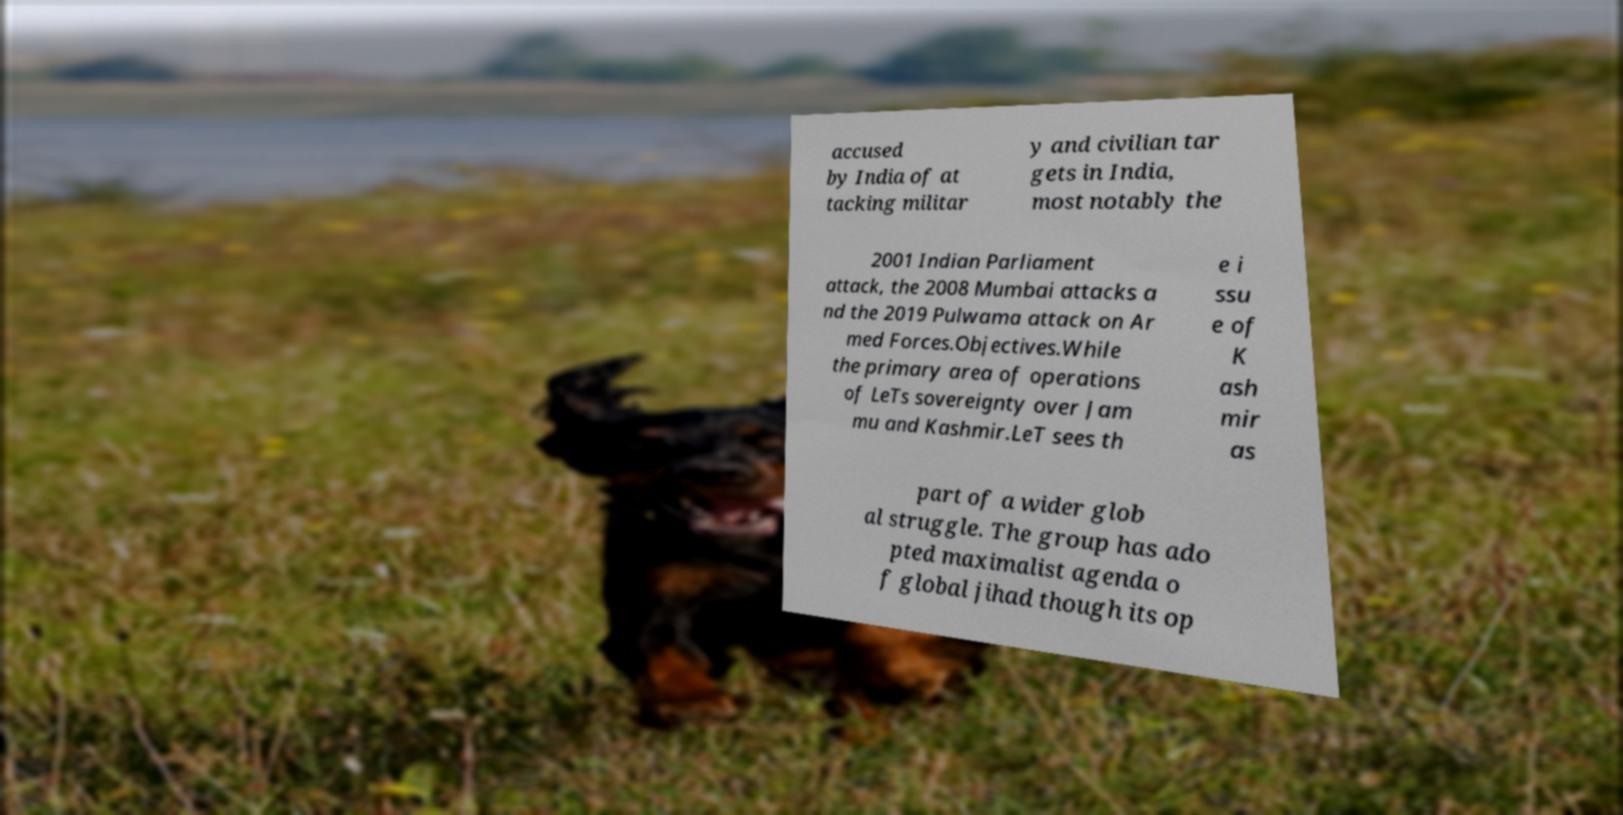Please read and relay the text visible in this image. What does it say? accused by India of at tacking militar y and civilian tar gets in India, most notably the 2001 Indian Parliament attack, the 2008 Mumbai attacks a nd the 2019 Pulwama attack on Ar med Forces.Objectives.While the primary area of operations of LeTs sovereignty over Jam mu and Kashmir.LeT sees th e i ssu e of K ash mir as part of a wider glob al struggle. The group has ado pted maximalist agenda o f global jihad though its op 